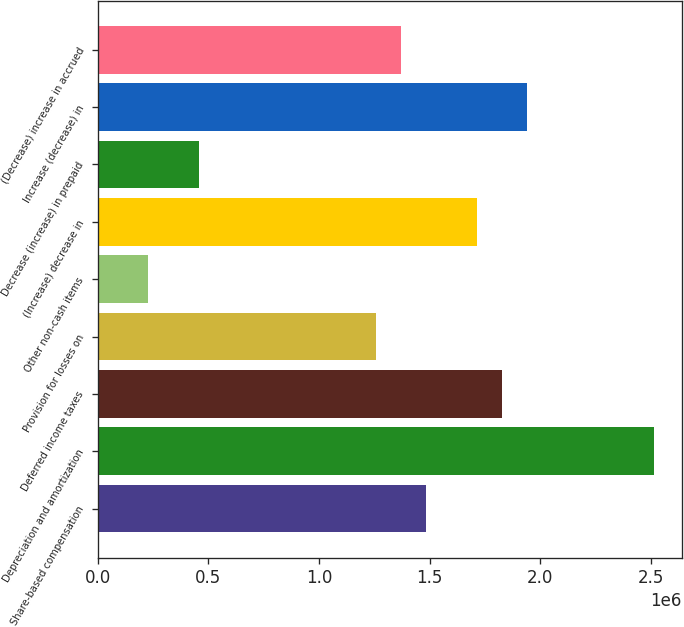Convert chart to OTSL. <chart><loc_0><loc_0><loc_500><loc_500><bar_chart><fcel>Share-based compensation<fcel>Depreciation and amortization<fcel>Deferred income taxes<fcel>Provision for losses on<fcel>Other non-cash items<fcel>(Increase) decrease in<fcel>Decrease (increase) in prepaid<fcel>Increase (decrease) in<fcel>(Decrease) increase in accrued<nl><fcel>1.48455e+06<fcel>2.51231e+06<fcel>1.82714e+06<fcel>1.25616e+06<fcel>228398<fcel>1.71294e+06<fcel>456789<fcel>1.94133e+06<fcel>1.37035e+06<nl></chart> 